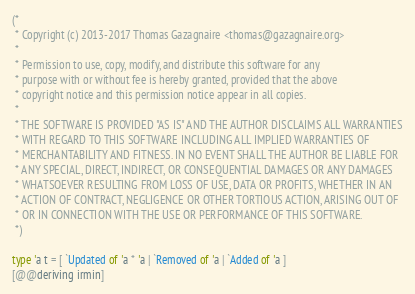<code> <loc_0><loc_0><loc_500><loc_500><_OCaml_>(*
 * Copyright (c) 2013-2017 Thomas Gazagnaire <thomas@gazagnaire.org>
 *
 * Permission to use, copy, modify, and distribute this software for any
 * purpose with or without fee is hereby granted, provided that the above
 * copyright notice and this permission notice appear in all copies.
 *
 * THE SOFTWARE IS PROVIDED "AS IS" AND THE AUTHOR DISCLAIMS ALL WARRANTIES
 * WITH REGARD TO THIS SOFTWARE INCLUDING ALL IMPLIED WARRANTIES OF
 * MERCHANTABILITY AND FITNESS. IN NO EVENT SHALL THE AUTHOR BE LIABLE FOR
 * ANY SPECIAL, DIRECT, INDIRECT, OR CONSEQUENTIAL DAMAGES OR ANY DAMAGES
 * WHATSOEVER RESULTING FROM LOSS OF USE, DATA OR PROFITS, WHETHER IN AN
 * ACTION OF CONTRACT, NEGLIGENCE OR OTHER TORTIOUS ACTION, ARISING OUT OF
 * OR IN CONNECTION WITH THE USE OR PERFORMANCE OF THIS SOFTWARE.
 *)

type 'a t = [ `Updated of 'a * 'a | `Removed of 'a | `Added of 'a ]
[@@deriving irmin]
</code> 